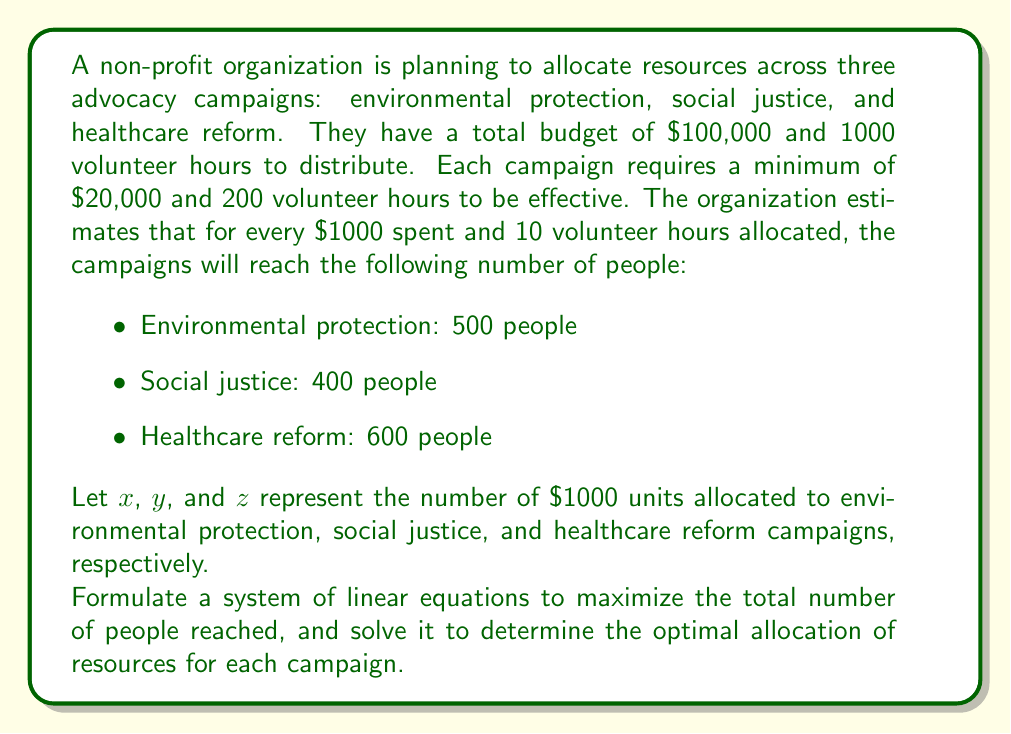Can you answer this question? Let's approach this problem step by step:

1) First, we need to set up our constraints:

   Total budget: $x + y + z = 100$ (as the budget is $100,000)
   Total volunteer hours: $x + y + z = 100$ (as there are 1000 hours, and each unit represents 10 hours)
   Minimum allocation for each campaign: $x \geq 20$, $y \geq 20$, $z \geq 20$

2) Our objective function to maximize is:

   $P = 500x + 400y + 600z$

   Where P is the total number of people reached.

3) To solve this linear programming problem, we can use the simplex method. However, given the constraints, we can simplify our solution.

4) Since the healthcare reform campaign reaches the most people per unit of resources (600), we should allocate as much as possible to this campaign after meeting the minimum requirements for all campaigns.

5) Allocating the minimum to each campaign:
   $20 + 20 + 20 = 60$

6) Remaining resources to allocate:
   $100 - 60 = 40$

7) We allocate all remaining resources to healthcare reform:
   $x = 20$, $y = 20$, $z = 60$

8) Let's verify that this satisfies all constraints:
   Budget: $20 + 20 + 60 = 100$ ✓
   Volunteer hours: $20 + 20 + 60 = 100$ ✓
   Minimum allocations: All campaigns receive at least 20 units ✓

9) Calculate the total number of people reached:
   $P = 500(20) + 400(20) + 600(60) = 10,000 + 8,000 + 36,000 = 54,000$
Answer: The optimal allocation of resources is:
Environmental protection: $20,000 and 200 volunteer hours
Social justice: $20,000 and 200 volunteer hours
Healthcare reform: $60,000 and 600 volunteer hours

This allocation will reach a maximum of 54,000 people. 